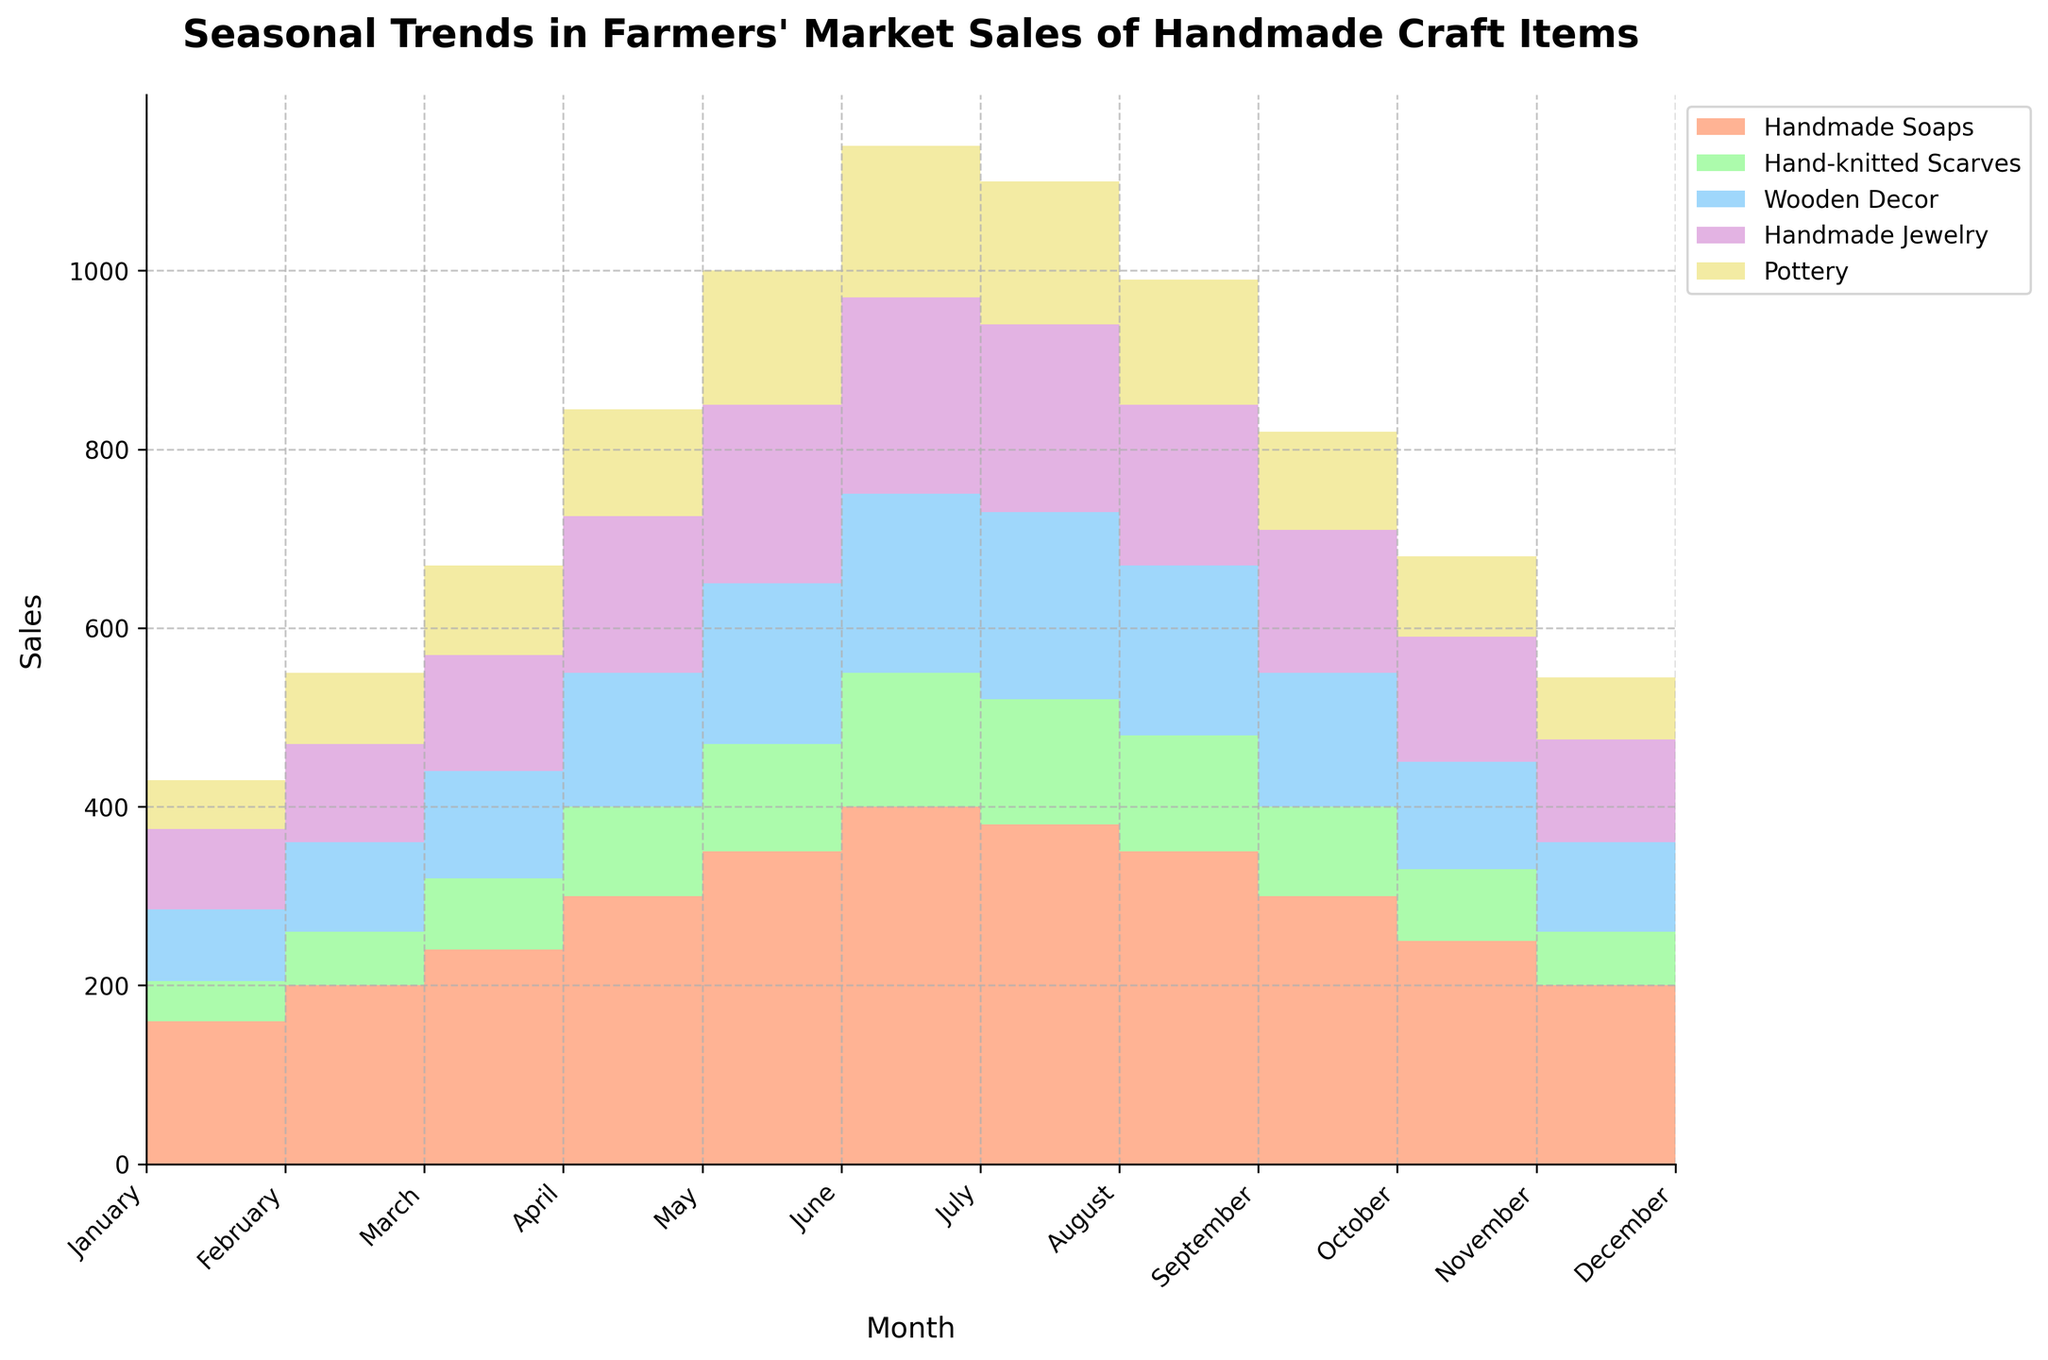How many categories of handmade craft items are shown in the chart? The chart displays sales trends for different handmade craft items. The categories can be identified by their respective labels and colors in the legend.
Answer: 5 What is the highest sales value for Handmade Soaps and in which month does it occur? By observing the step area chart, the highest point of the layer representing Handmade Soaps is noted in July, showcasing the peak sales value.
Answer: 400, July What's the difference in sales between Hand-knitted Scarves and Pottery in April? First, locate the sales values for both items in April on the step area chart. Hand-knitted Scarves have sales of 80, and Pottery has sales of 100. The difference is calculated as 100 - 80.
Answer: 20 Which month has the lowest total sales across all categories? To determine this, observe the overall height of all stacked areas together for each month. The month with the shortest total height layer represents the lowest total sales.
Answer: February How do the sales for Wooden Decor change from January to July? Track the stacked area layer corresponding to Wooden Decor throughout these months. Identify the step points to note the progression from 75 in January to 200 in July.
Answer: Increase from 75 to 200 What are the combined sales of Handmade Jewelry and Hand-knitted Scarves in May? To find the combined sales, observe the sales values for both categories in May. Handmade Jewelry has sales of 175, and Hand-knitted Scarves have sales of 100. Summing these values gives 175 + 100.
Answer: 275 Compare the sales of Pottery in June and September. Which month has higher sales? Examine the step points for Pottery sales in June and September. There are 150 sales in June compared to 140 in September. Thus, June has higher sales.
Answer: June What trend do you observe for Hand-knitted Scarves from January to December? Analyze the step area indicating Hand-knitted Scarves month by month. Sales start at 50 in January, peak at 150 in July, and decrease back to 60 by December. Observe the overall pattern of rise and fall.
Answer: Rise then fall Which category consistently has the lowest sales across the year? Compare the height of the stacked areas for each category throughout the year. The category with the smallest area portion consistently across months shows the lowest sales.
Answer: Hand-knitted Scarves What is the average sales value of Handmade Soaps in the first quarter (January to March)? Add the sales values of Handmade Soaps for January, February, and March: 150, 160, and 200, respectively. Then divide by the number of months, which is three.
Answer: 170 